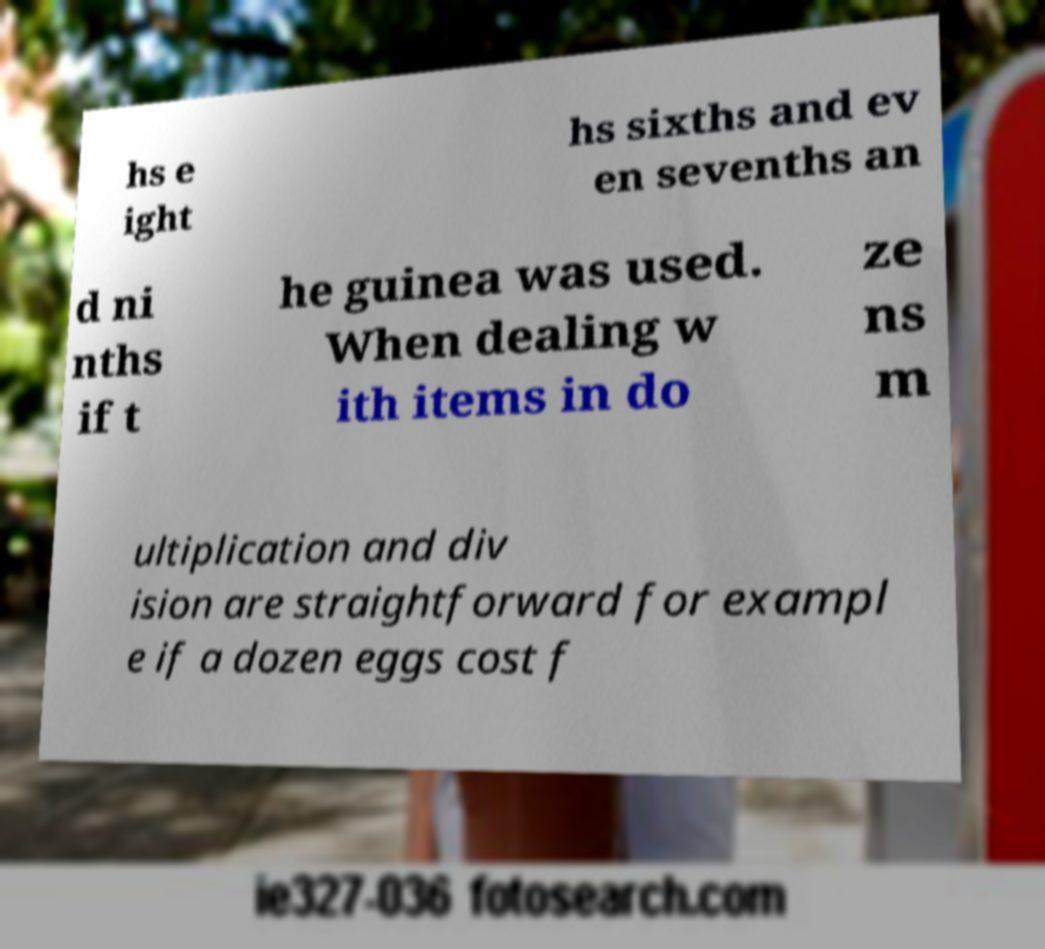I need the written content from this picture converted into text. Can you do that? hs e ight hs sixths and ev en sevenths an d ni nths if t he guinea was used. When dealing w ith items in do ze ns m ultiplication and div ision are straightforward for exampl e if a dozen eggs cost f 